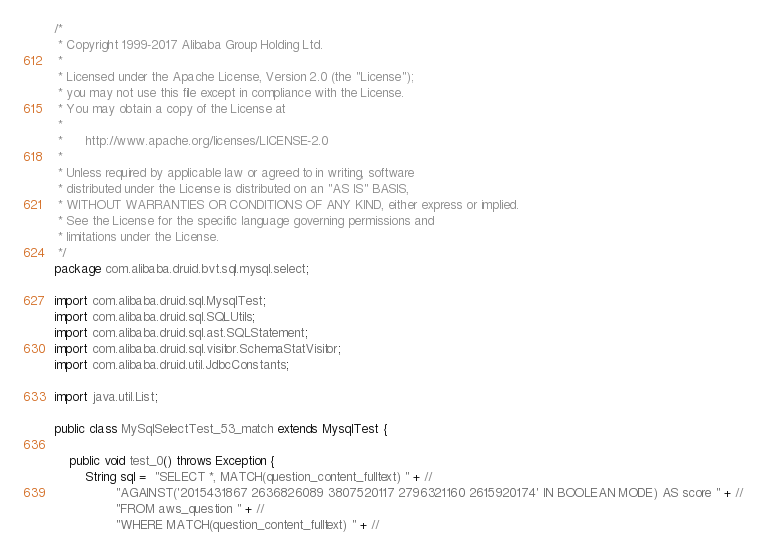Convert code to text. <code><loc_0><loc_0><loc_500><loc_500><_Java_>/*
 * Copyright 1999-2017 Alibaba Group Holding Ltd.
 *
 * Licensed under the Apache License, Version 2.0 (the "License");
 * you may not use this file except in compliance with the License.
 * You may obtain a copy of the License at
 *
 *      http://www.apache.org/licenses/LICENSE-2.0
 *
 * Unless required by applicable law or agreed to in writing, software
 * distributed under the License is distributed on an "AS IS" BASIS,
 * WITHOUT WARRANTIES OR CONDITIONS OF ANY KIND, either express or implied.
 * See the License for the specific language governing permissions and
 * limitations under the License.
 */
package com.alibaba.druid.bvt.sql.mysql.select;

import com.alibaba.druid.sql.MysqlTest;
import com.alibaba.druid.sql.SQLUtils;
import com.alibaba.druid.sql.ast.SQLStatement;
import com.alibaba.druid.sql.visitor.SchemaStatVisitor;
import com.alibaba.druid.util.JdbcConstants;

import java.util.List;

public class MySqlSelectTest_53_match extends MysqlTest {

    public void test_0() throws Exception {
        String sql =  "SELECT *, MATCH(question_content_fulltext) " + //
                "AGAINST('2015431867 2636826089 3807520117 2796321160 2615920174' IN BOOLEAN MODE) AS score " + //
                "FROM aws_question " + //
                "WHERE MATCH(question_content_fulltext) " + //</code> 